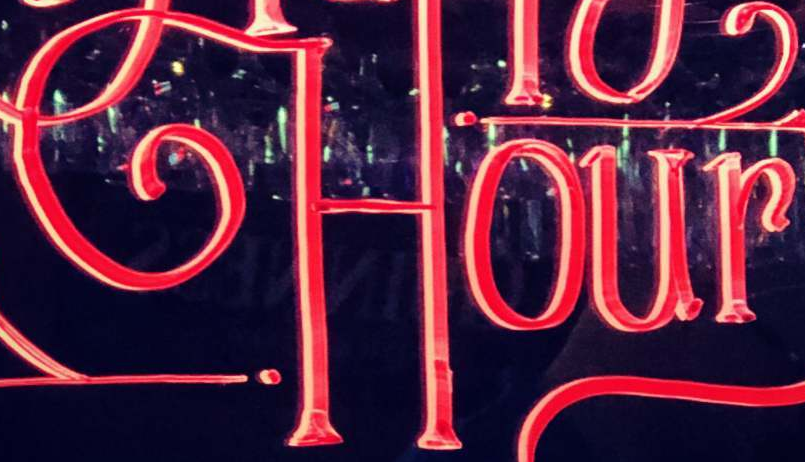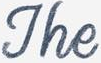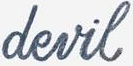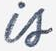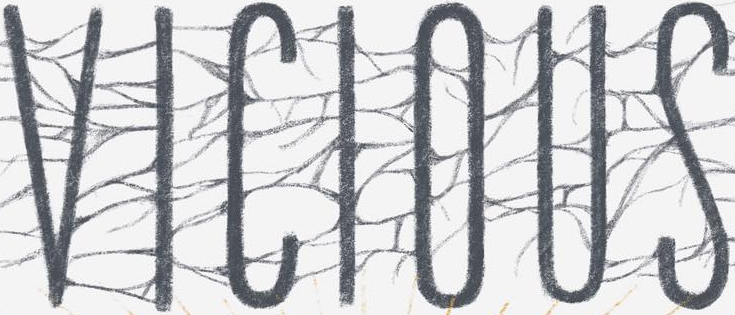Read the text from these images in sequence, separated by a semicolon. Hour; The; devil; is; VICIOUS 